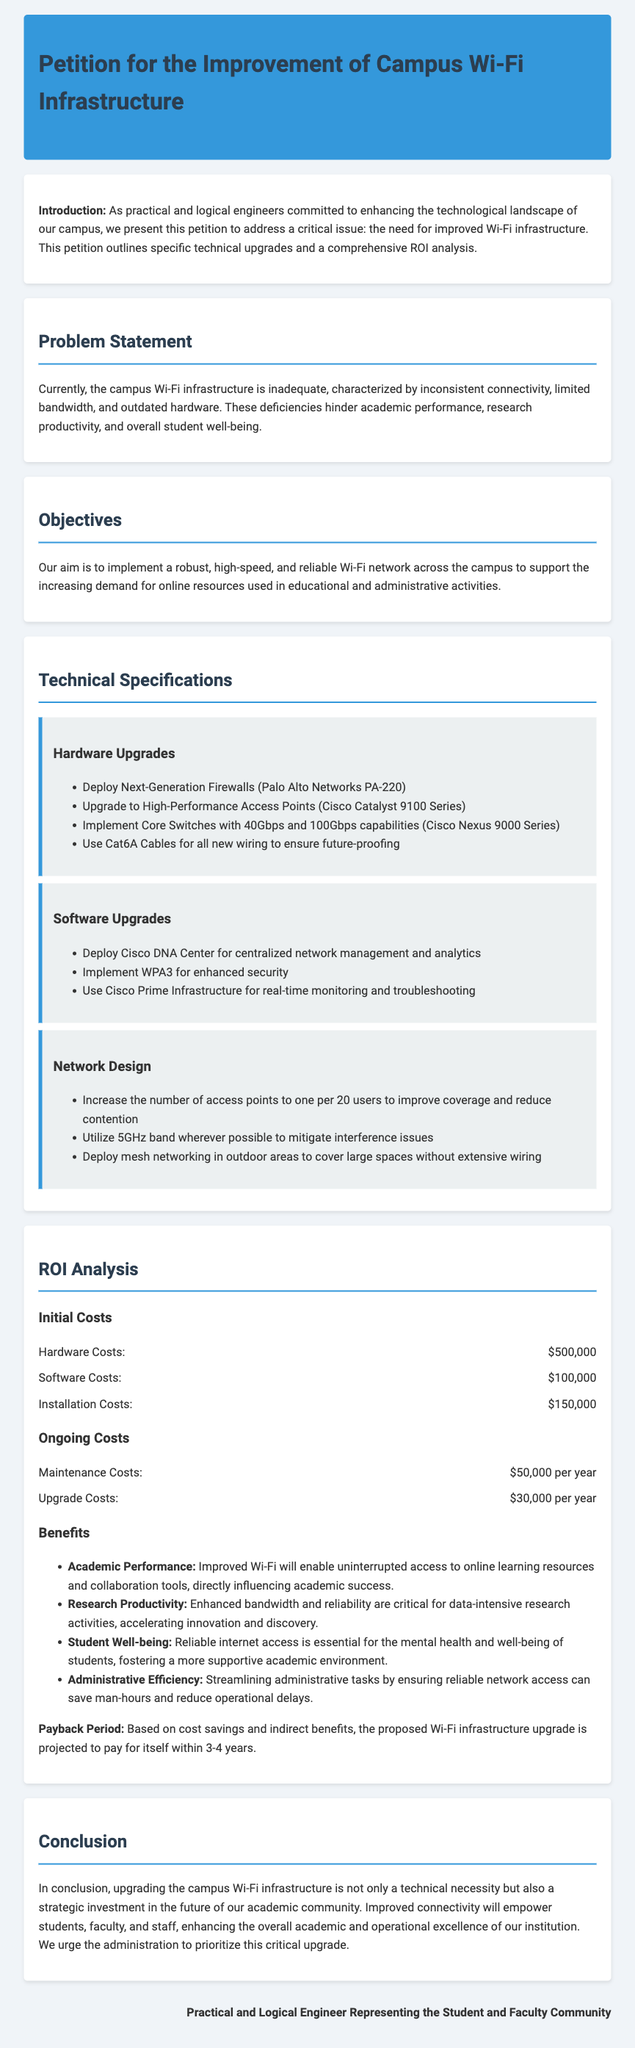What is the title of the petition? The title is the main heading of the document.
Answer: Petition for the Improvement of Campus Wi-Fi Infrastructure How much are the initial hardware costs? The initial hardware costs are detailed in the ROI analysis section of the document.
Answer: $500,000 What is the proposed payback period for the upgrade? The payback period is mentioned in the ROI analysis section.
Answer: 3-4 years Which access point series is proposed for upgrade? The proposed access point series is found in the technical specifications.
Answer: Cisco Catalyst 9100 Series What is the primary reason for upgrading the Wi-Fi infrastructure? The introduction outlines the critical issue needing address.
Answer: Inadequate Wi-Fi infrastructure What kind of management tool will be deployed? The software upgrades mention a specific tool for network management.
Answer: Cisco DNA Center What type of cables will be used for new wiring? The technical specifications list the type of cables for new wiring.
Answer: Cat6A Cables What is the annual maintenance cost? The ongoing costs section provides details on maintenance expenses.
Answer: $50,000 per year What type of security will be implemented in the software upgrades? The software upgrades highlight a specific security implementation.
Answer: WPA3 